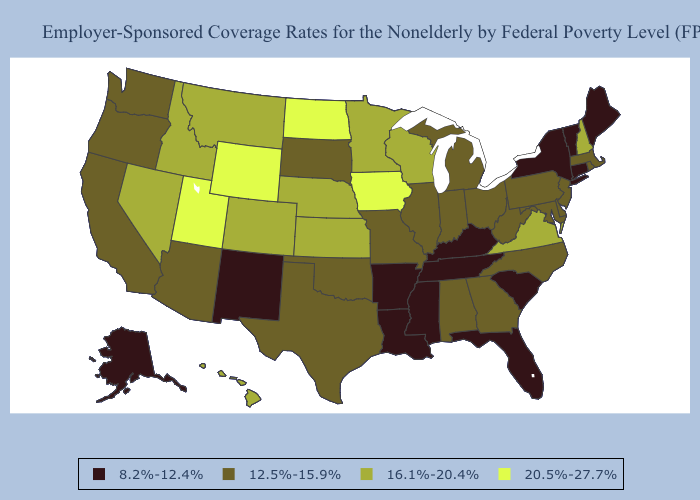Name the states that have a value in the range 16.1%-20.4%?
Keep it brief. Colorado, Hawaii, Idaho, Kansas, Minnesota, Montana, Nebraska, Nevada, New Hampshire, Virginia, Wisconsin. Which states have the lowest value in the Northeast?
Write a very short answer. Connecticut, Maine, New York, Vermont. Does South Carolina have the lowest value in the USA?
Answer briefly. Yes. What is the highest value in states that border Florida?
Answer briefly. 12.5%-15.9%. Among the states that border Vermont , which have the highest value?
Write a very short answer. New Hampshire. What is the lowest value in states that border Nevada?
Concise answer only. 12.5%-15.9%. Name the states that have a value in the range 8.2%-12.4%?
Concise answer only. Alaska, Arkansas, Connecticut, Florida, Kentucky, Louisiana, Maine, Mississippi, New Mexico, New York, South Carolina, Tennessee, Vermont. What is the highest value in the Northeast ?
Be succinct. 16.1%-20.4%. Does the first symbol in the legend represent the smallest category?
Answer briefly. Yes. Is the legend a continuous bar?
Concise answer only. No. Name the states that have a value in the range 12.5%-15.9%?
Short answer required. Alabama, Arizona, California, Delaware, Georgia, Illinois, Indiana, Maryland, Massachusetts, Michigan, Missouri, New Jersey, North Carolina, Ohio, Oklahoma, Oregon, Pennsylvania, Rhode Island, South Dakota, Texas, Washington, West Virginia. What is the value of Kansas?
Write a very short answer. 16.1%-20.4%. Does New York have the lowest value in the USA?
Be succinct. Yes. What is the lowest value in the USA?
Give a very brief answer. 8.2%-12.4%. What is the lowest value in states that border Nebraska?
Be succinct. 12.5%-15.9%. 